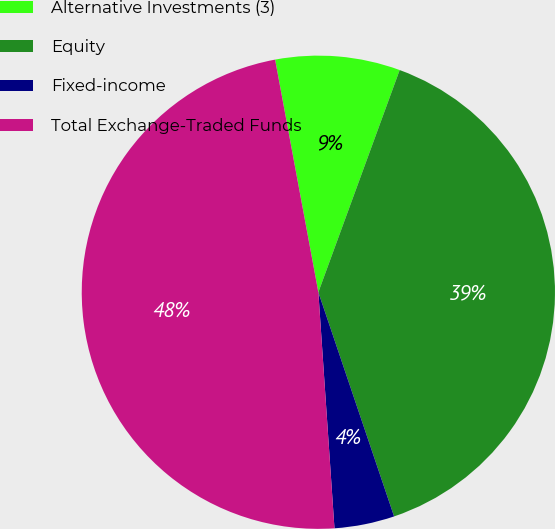<chart> <loc_0><loc_0><loc_500><loc_500><pie_chart><fcel>Alternative Investments (3)<fcel>Equity<fcel>Fixed-income<fcel>Total Exchange-Traded Funds<nl><fcel>8.51%<fcel>39.23%<fcel>4.1%<fcel>48.16%<nl></chart> 